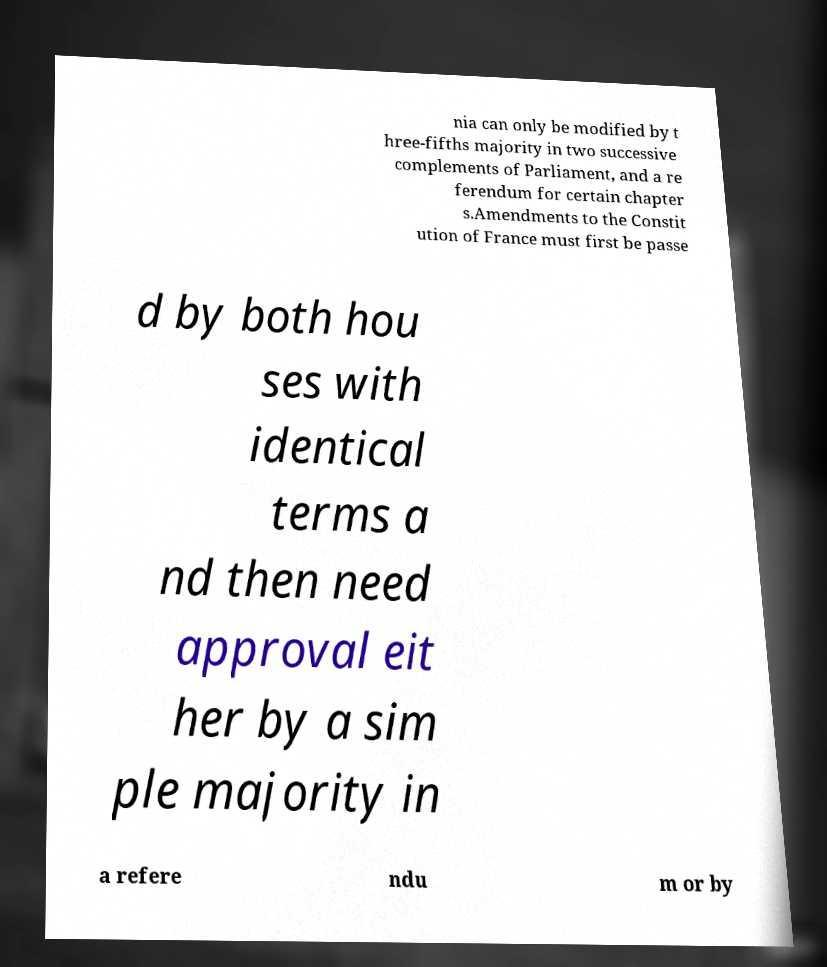What messages or text are displayed in this image? I need them in a readable, typed format. nia can only be modified by t hree-fifths majority in two successive complements of Parliament, and a re ferendum for certain chapter s.Amendments to the Constit ution of France must first be passe d by both hou ses with identical terms a nd then need approval eit her by a sim ple majority in a refere ndu m or by 